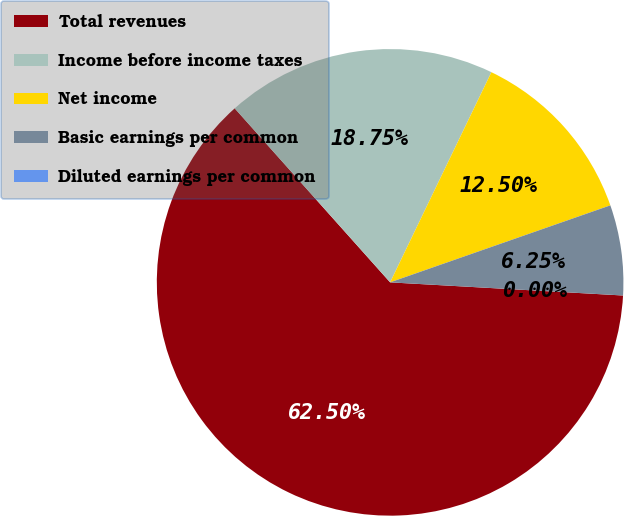Convert chart. <chart><loc_0><loc_0><loc_500><loc_500><pie_chart><fcel>Total revenues<fcel>Income before income taxes<fcel>Net income<fcel>Basic earnings per common<fcel>Diluted earnings per common<nl><fcel>62.5%<fcel>18.75%<fcel>12.5%<fcel>6.25%<fcel>0.0%<nl></chart> 